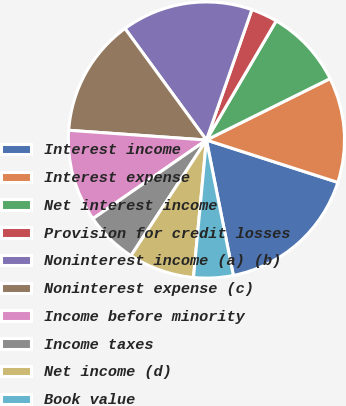<chart> <loc_0><loc_0><loc_500><loc_500><pie_chart><fcel>Interest income<fcel>Interest expense<fcel>Net interest income<fcel>Provision for credit losses<fcel>Noninterest income (a) (b)<fcel>Noninterest expense (c)<fcel>Income before minority<fcel>Income taxes<fcel>Net income (d)<fcel>Book value<nl><fcel>16.91%<fcel>12.3%<fcel>9.23%<fcel>3.09%<fcel>15.38%<fcel>13.84%<fcel>10.77%<fcel>6.16%<fcel>7.7%<fcel>4.62%<nl></chart> 